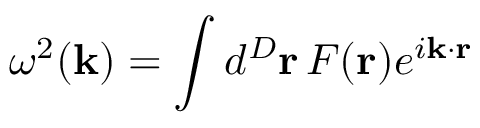<formula> <loc_0><loc_0><loc_500><loc_500>\omega ^ { 2 } ( { k } ) = \int d ^ { D } { r } \, F ( { r } ) e ^ { i { k } \cdot { r } }</formula> 